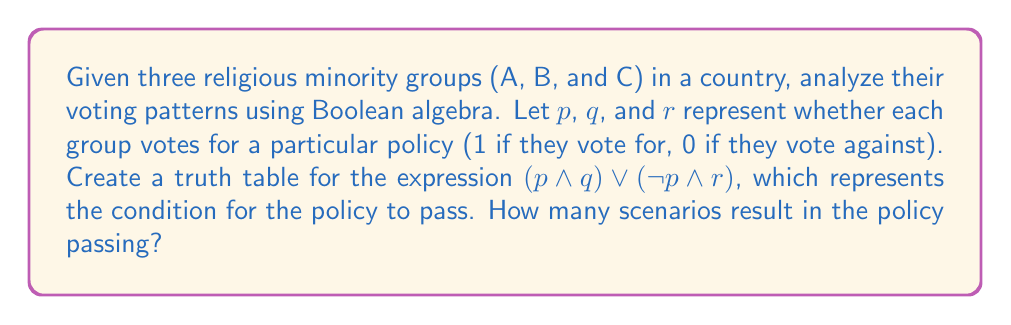Teach me how to tackle this problem. To solve this problem, we need to create a truth table for the given Boolean expression and count the number of scenarios where the result is true (1).

Step 1: Create the truth table
Let's create a truth table with columns for $p$, $q$, $r$, $(p \land q)$, $(\neg p \land r)$, and the final result $(p \land q) \lor (\neg p \land r)$.

$$
\begin{array}{|c|c|c|c|c|c|}
\hline
p & q & r & (p \land q) & (\neg p \land r) & (p \land q) \lor (\neg p \land r) \\
\hline
0 & 0 & 0 & 0 & 0 & 0 \\
0 & 0 & 1 & 0 & 1 & 1 \\
0 & 1 & 0 & 0 & 0 & 0 \\
0 & 1 & 1 & 0 & 1 & 1 \\
1 & 0 & 0 & 0 & 0 & 0 \\
1 & 0 & 1 & 0 & 0 & 0 \\
1 & 1 & 0 & 1 & 0 & 1 \\
1 & 1 & 1 & 1 & 0 & 1 \\
\hline
\end{array}
$$

Step 2: Count the number of scenarios where the policy passes
From the truth table, we can see that there are 4 scenarios where the final result is 1 (true), meaning the policy passes.

These scenarios are:
1. When $p = 0$, $q = 0$, and $r = 1$
2. When $p = 0$, $q = 1$, and $r = 1$
3. When $p = 1$, $q = 1$, and $r = 0$
4. When $p = 1$, $q = 1$, and $r = 1$

Therefore, there are 4 scenarios in which the policy passes according to the given Boolean expression.
Answer: 4 